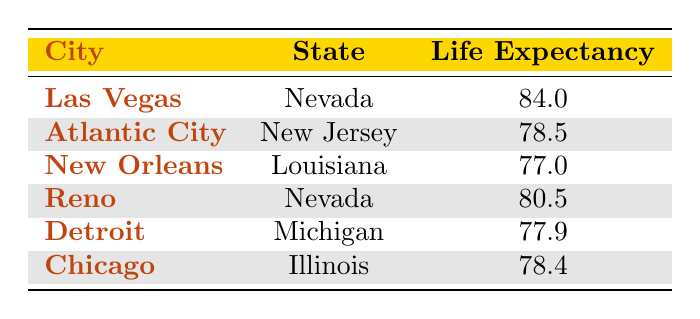What is the average life expectancy in Las Vegas, NV? According to the table, the life expectancy in Las Vegas, NV is listed directly as 84.0.
Answer: 84.0 What notable casinos are in Atlantic City, NJ? The table lists the notable casinos in Atlantic City, NJ as Borgata, Caesars Atlantic City, and Harrah's Resort.
Answer: Borgata, Caesars Atlantic City, Harrah's Resort Which city has the highest life expectancy? By comparing the life expectancy values from the table, Las Vegas, NV has the highest life expectancy at 84.0.
Answer: Las Vegas, NV Is life expectancy in New Orleans, LA greater than that in Detroit, MI? The life expectancy in New Orleans is 77.0, while in Detroit, it is 77.9. Since 77.0 is not greater than 77.9, the answer is no.
Answer: No Calculate the average life expectancy of cities with a casino industry presence. The cities with a casino industry presence and their life expectancies are Las Vegas (84.0), Atlantic City (78.5), New Orleans (77.0), Reno (80.5), and Detroit (77.9). To find the average: (84.0 + 78.5 + 77.0 + 80.5 + 77.9) / 5 = 79.82.
Answer: 79.82 How many cities in the table have a casino industry presence? By checking the data, there are five cities (Las Vegas, Atlantic City, New Orleans, Reno, and Detroit) that have a casino industry presence.
Answer: 5 Is Chicago included in the cities with a casino industry presence? The table shows that Chicago does not have a casino industry presence, as indicated by the corresponding entry.
Answer: No What is the difference in life expectancy between Las Vegas and New Orleans? Life expectancy in Las Vegas is 84.0 and in New Orleans is 77.0. The difference is 84.0 - 77.0 = 7.0.
Answer: 7.0 